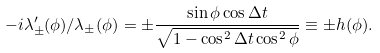Convert formula to latex. <formula><loc_0><loc_0><loc_500><loc_500>- i \lambda _ { \pm } ^ { \prime } ( \phi ) / \lambda _ { \pm } ( \phi ) = \pm \frac { \sin \phi \cos \Delta t } { \sqrt { 1 - \cos ^ { 2 } \Delta t \cos ^ { 2 } \phi } } \equiv \pm h ( \phi ) .</formula> 